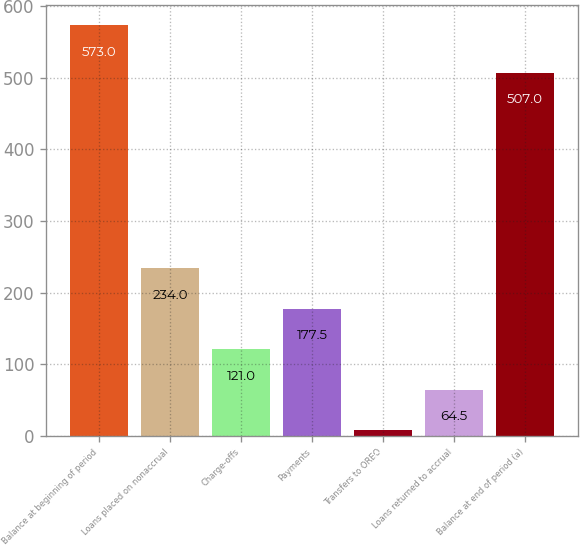<chart> <loc_0><loc_0><loc_500><loc_500><bar_chart><fcel>Balance at beginning of period<fcel>Loans placed on nonaccrual<fcel>Charge-offs<fcel>Payments<fcel>Transfers to OREO<fcel>Loans returned to accrual<fcel>Balance at end of period (a)<nl><fcel>573<fcel>234<fcel>121<fcel>177.5<fcel>8<fcel>64.5<fcel>507<nl></chart> 